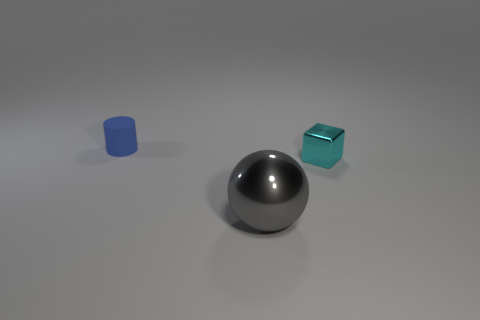Is there a cyan object that has the same material as the gray ball?
Make the answer very short. Yes. The small cylinder is what color?
Offer a terse response. Blue. How big is the shiny object on the right side of the big gray shiny object?
Ensure brevity in your answer.  Small. How many cylinders are the same color as the large shiny object?
Keep it short and to the point. 0. There is a tiny thing that is on the right side of the tiny blue matte thing; is there a big gray thing to the right of it?
Your answer should be compact. No. What color is the shiny thing that is the same size as the blue matte cylinder?
Make the answer very short. Cyan. Are there an equal number of blue rubber cylinders to the right of the gray metal ball and cyan things that are to the right of the cylinder?
Offer a very short reply. No. There is a small object behind the small thing that is right of the metallic ball; what is it made of?
Your response must be concise. Rubber. What number of objects are cyan things or large blue metal cylinders?
Give a very brief answer. 1. Is the number of large gray objects less than the number of big red spheres?
Make the answer very short. No. 